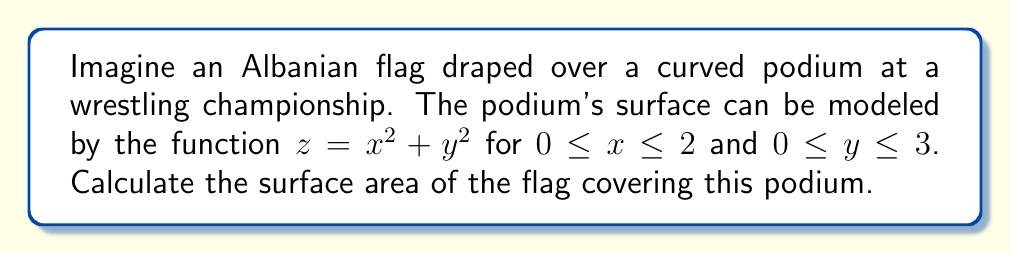Give your solution to this math problem. To solve this problem, we'll use the surface area formula for a parametric surface:

$$A = \iint_S \sqrt{1 + (\frac{\partial z}{\partial x})^2 + (\frac{\partial z}{\partial y})^2} \,dA$$

Step 1: Find partial derivatives
$\frac{\partial z}{\partial x} = 2x$
$\frac{\partial z}{\partial y} = 2y$

Step 2: Substitute into the surface area formula
$$A = \int_0^3 \int_0^2 \sqrt{1 + (2x)^2 + (2y)^2} \,dx\,dy$$

Step 3: Simplify the integrand
$$A = \int_0^3 \int_0^2 \sqrt{1 + 4x^2 + 4y^2} \,dx\,dy$$

Step 4: This integral is difficult to evaluate analytically. We'll use numerical integration.

Step 5: Using a numerical integration method (e.g., Simpson's rule or a computer algebra system), we get:

$$A \approx 13.8362 \text{ square units}$$

This represents the approximate surface area of the Albanian flag draped over the curved podium.
Answer: $13.8362 \text{ square units}$ 